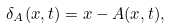Convert formula to latex. <formula><loc_0><loc_0><loc_500><loc_500>\delta _ { A } ( x , t ) = x - A ( x , t ) ,</formula> 